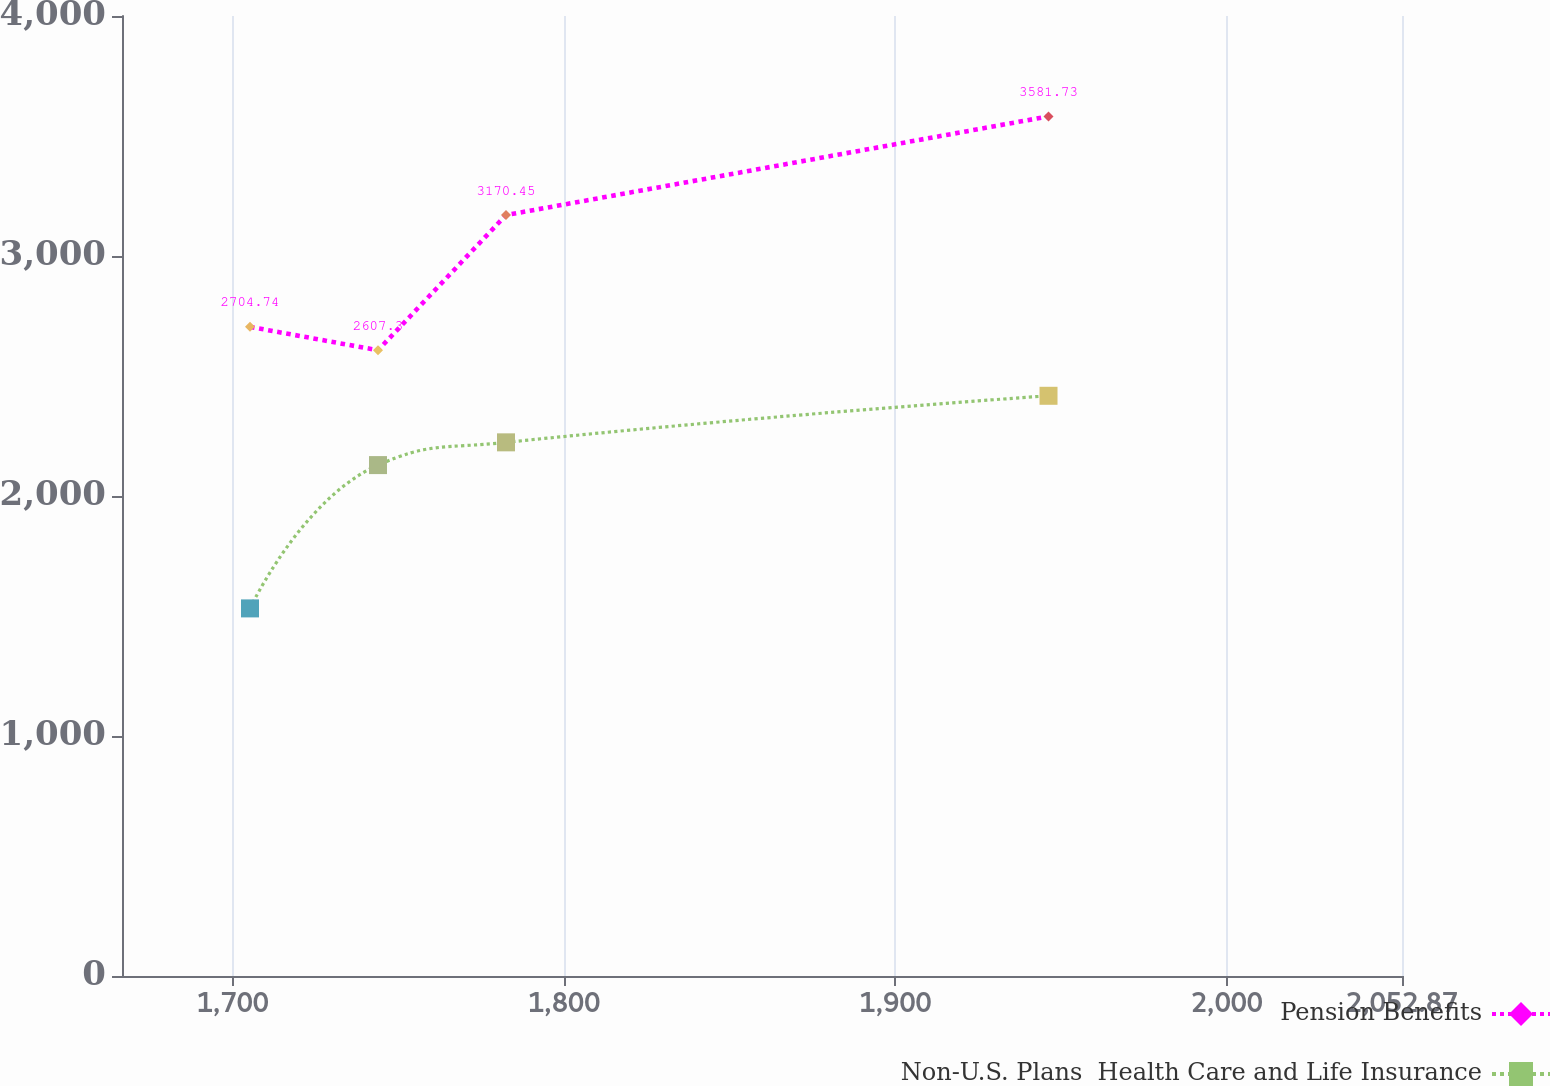Convert chart. <chart><loc_0><loc_0><loc_500><loc_500><line_chart><ecel><fcel>Pension Benefits<fcel>Non-U.S. Plans  Health Care and Life Insurance<nl><fcel>1705.2<fcel>2704.74<fcel>1531.67<nl><fcel>1743.83<fcel>2607.3<fcel>2128.79<nl><fcel>1782.46<fcel>3170.45<fcel>2223.55<nl><fcel>1946.19<fcel>3581.73<fcel>2417.55<nl><fcel>2091.5<fcel>2802.18<fcel>2312.14<nl></chart> 